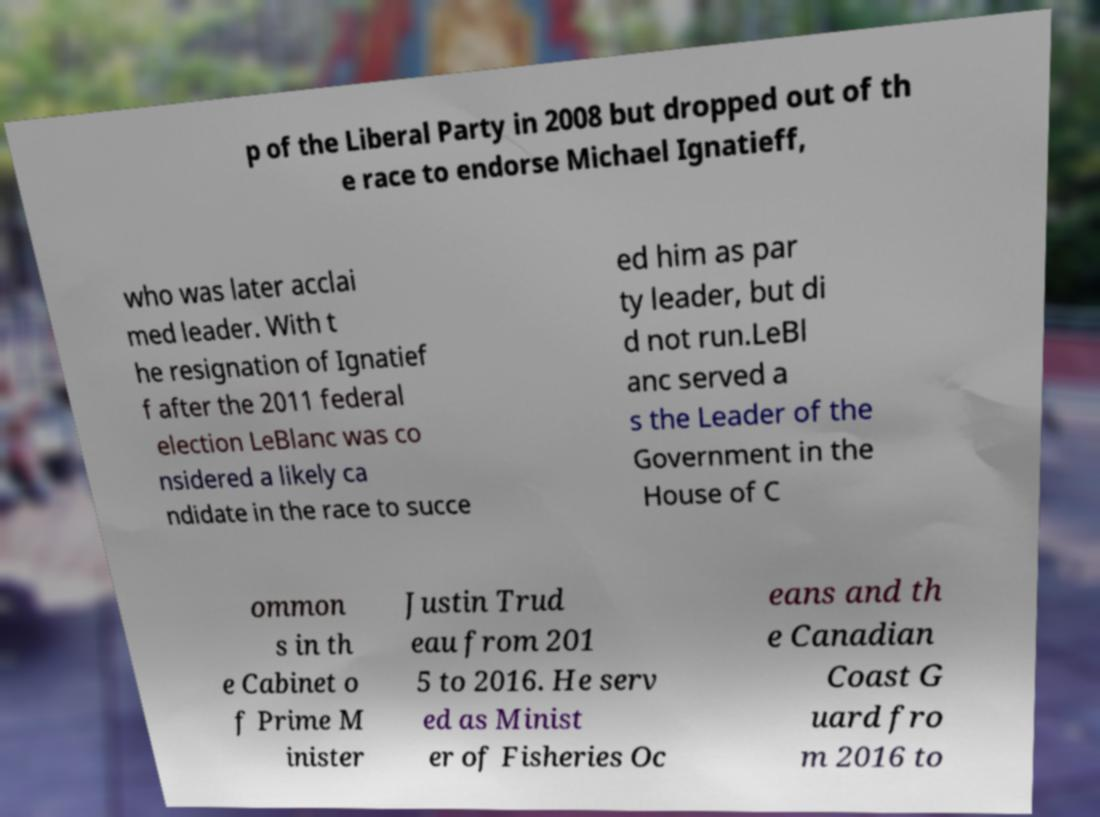Can you read and provide the text displayed in the image?This photo seems to have some interesting text. Can you extract and type it out for me? p of the Liberal Party in 2008 but dropped out of th e race to endorse Michael Ignatieff, who was later acclai med leader. With t he resignation of Ignatief f after the 2011 federal election LeBlanc was co nsidered a likely ca ndidate in the race to succe ed him as par ty leader, but di d not run.LeBl anc served a s the Leader of the Government in the House of C ommon s in th e Cabinet o f Prime M inister Justin Trud eau from 201 5 to 2016. He serv ed as Minist er of Fisheries Oc eans and th e Canadian Coast G uard fro m 2016 to 